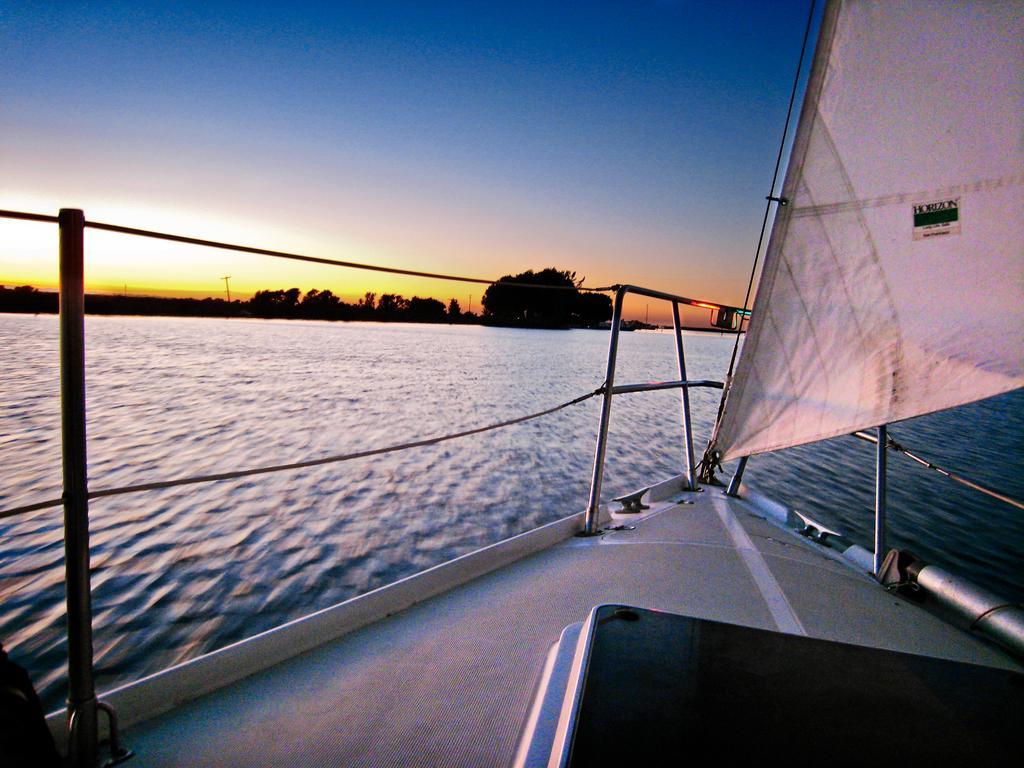Can you describe this image briefly? In this image there is a boat on the water, and in the background there are trees,sky. 